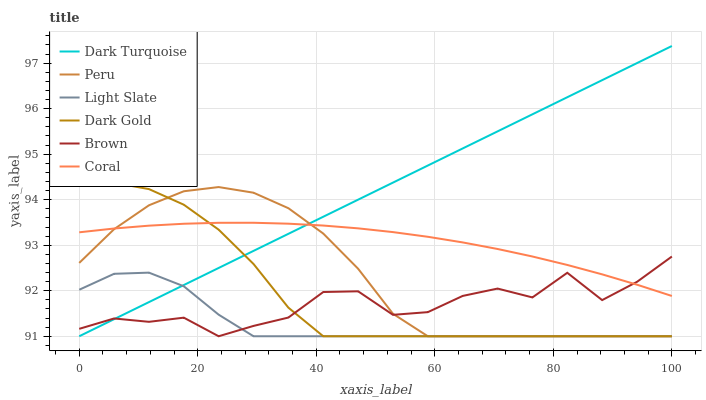Does Light Slate have the minimum area under the curve?
Answer yes or no. Yes. Does Dark Turquoise have the maximum area under the curve?
Answer yes or no. Yes. Does Dark Gold have the minimum area under the curve?
Answer yes or no. No. Does Dark Gold have the maximum area under the curve?
Answer yes or no. No. Is Dark Turquoise the smoothest?
Answer yes or no. Yes. Is Brown the roughest?
Answer yes or no. Yes. Is Dark Gold the smoothest?
Answer yes or no. No. Is Dark Gold the roughest?
Answer yes or no. No. Does Brown have the lowest value?
Answer yes or no. Yes. Does Coral have the lowest value?
Answer yes or no. No. Does Dark Turquoise have the highest value?
Answer yes or no. Yes. Does Dark Gold have the highest value?
Answer yes or no. No. Is Light Slate less than Coral?
Answer yes or no. Yes. Is Coral greater than Light Slate?
Answer yes or no. Yes. Does Dark Gold intersect Coral?
Answer yes or no. Yes. Is Dark Gold less than Coral?
Answer yes or no. No. Is Dark Gold greater than Coral?
Answer yes or no. No. Does Light Slate intersect Coral?
Answer yes or no. No. 